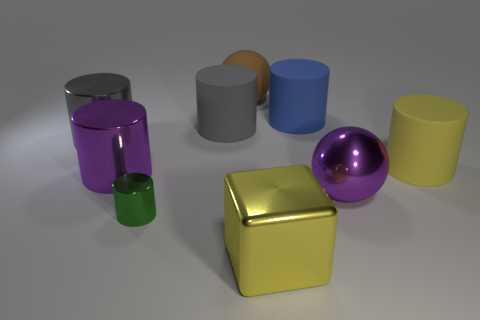What number of metallic balls are there?
Keep it short and to the point. 1. Is the blue matte object the same size as the yellow cube?
Offer a very short reply. Yes. What number of other objects are the same shape as the large gray metal thing?
Make the answer very short. 5. What material is the yellow thing that is behind the big metal cylinder that is in front of the yellow rubber cylinder?
Give a very brief answer. Rubber. There is a brown thing; are there any big rubber cylinders to the left of it?
Your response must be concise. Yes. There is a yellow matte cylinder; is its size the same as the ball that is on the right side of the big rubber sphere?
Your response must be concise. Yes. There is a blue thing that is the same shape as the green thing; what is its size?
Give a very brief answer. Large. Are there any other things that have the same material as the large purple sphere?
Offer a terse response. Yes. Does the purple shiny object that is in front of the large purple cylinder have the same size as the matte cylinder on the left side of the large yellow metal thing?
Offer a terse response. Yes. How many small things are purple rubber things or brown spheres?
Make the answer very short. 0. 